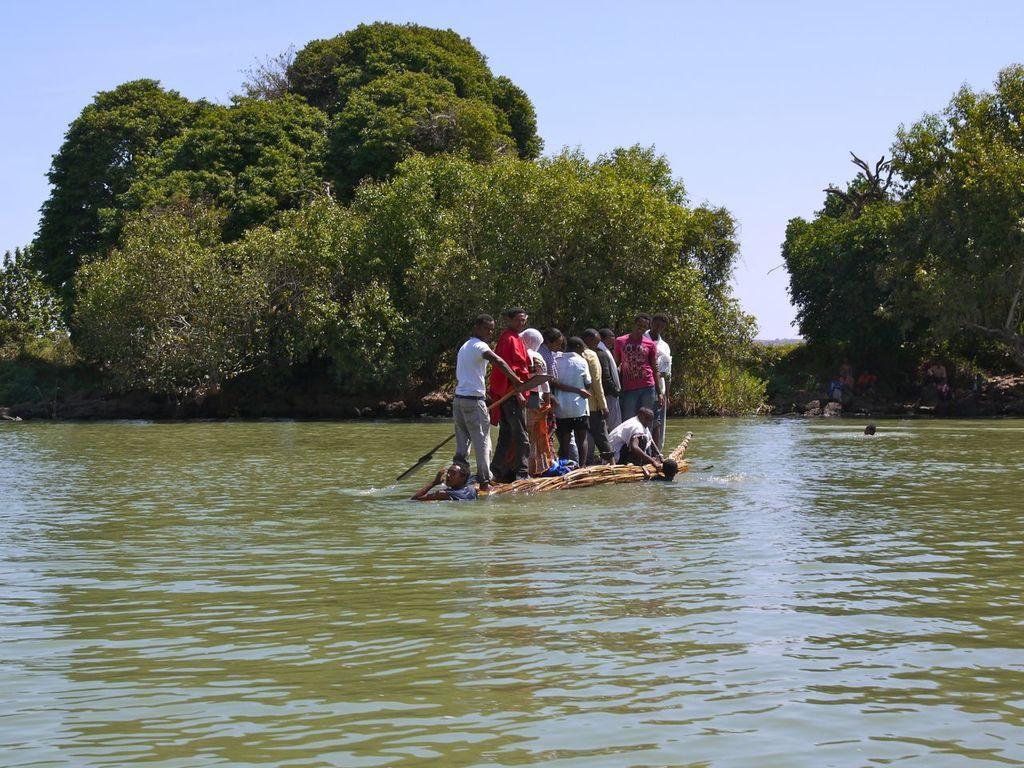In one or two sentences, can you explain what this image depicts? In this picture people are travelling on the boat made up of bamboo sticks towards the shore, where there are so many trees are present and at the end of the water there are some people sitting and standing and three people are swimming in the river. 